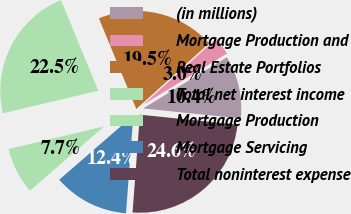Convert chart. <chart><loc_0><loc_0><loc_500><loc_500><pie_chart><fcel>(in millions)<fcel>Mortgage Production and<fcel>Real Estate Portfolios<fcel>Total net interest income<fcel>Mortgage Production<fcel>Mortgage Servicing<fcel>Total noninterest expense<nl><fcel>10.37%<fcel>2.96%<fcel>19.53%<fcel>22.48%<fcel>7.67%<fcel>12.44%<fcel>24.56%<nl></chart> 